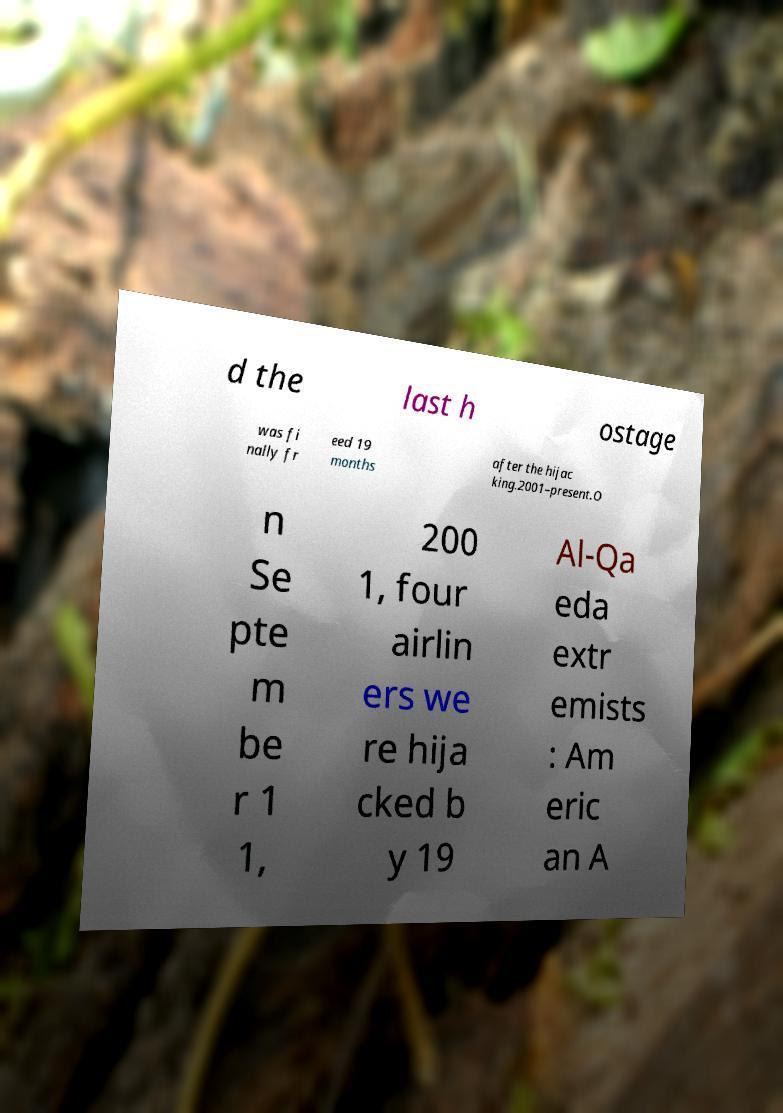There's text embedded in this image that I need extracted. Can you transcribe it verbatim? d the last h ostage was fi nally fr eed 19 months after the hijac king.2001–present.O n Se pte m be r 1 1, 200 1, four airlin ers we re hija cked b y 19 Al-Qa eda extr emists : Am eric an A 